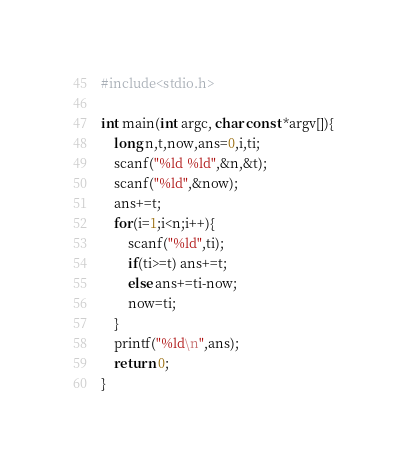<code> <loc_0><loc_0><loc_500><loc_500><_C_>#include<stdio.h>

int main(int argc, char const *argv[]){
	long n,t,now,ans=0,i,ti;
	scanf("%ld %ld",&n,&t);
	scanf("%ld",&now);
	ans+=t;
	for(i=1;i<n;i++){
		scanf("%ld",ti);
		if(ti>=t) ans+=t;
		else ans+=ti-now;
		now=ti;
	}
	printf("%ld\n",ans);
	return 0;
}</code> 